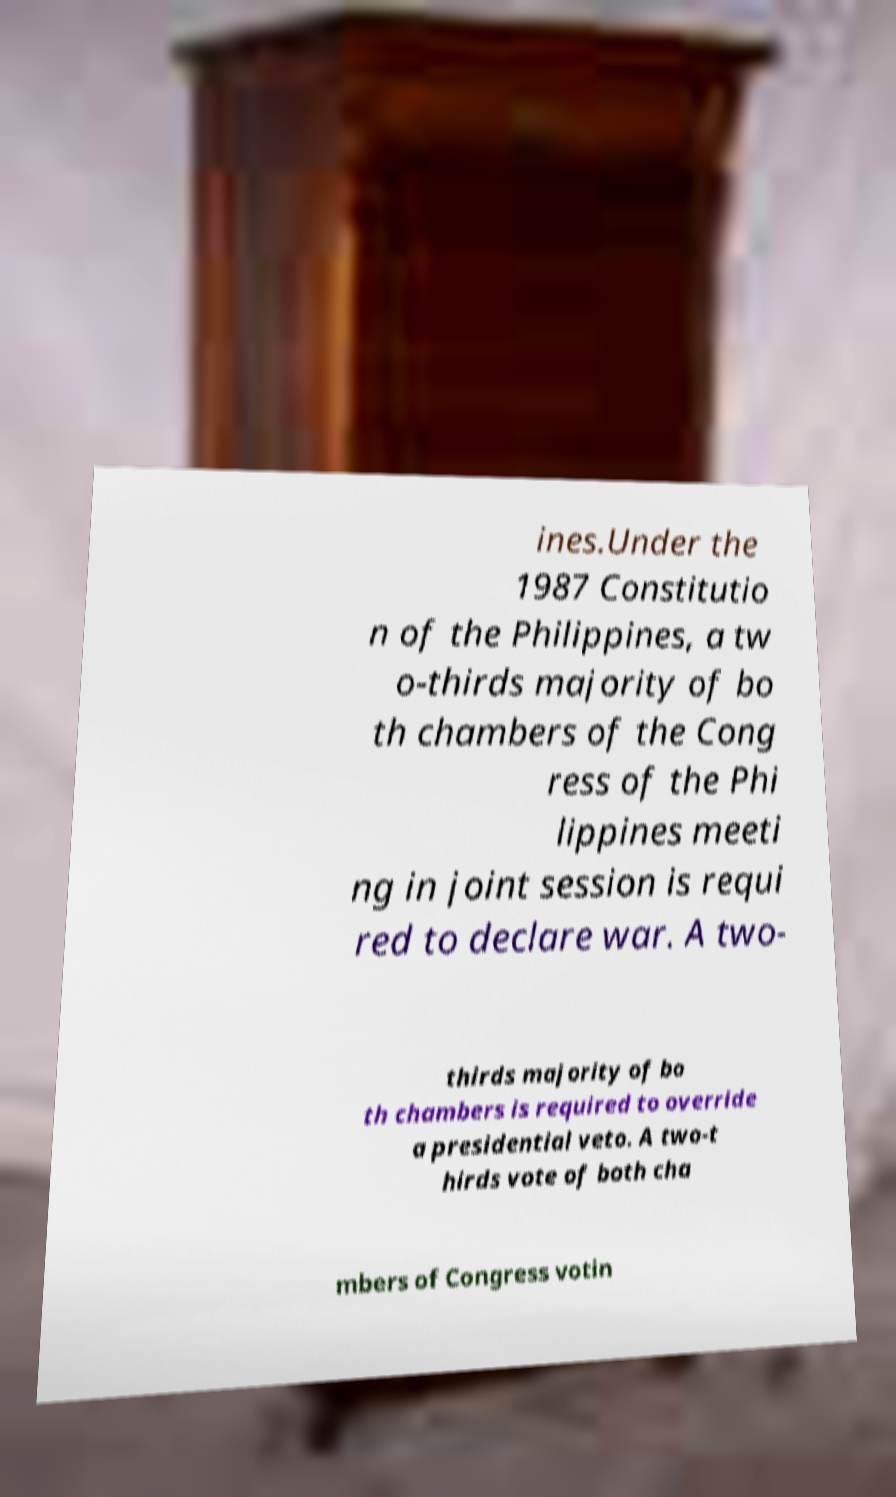Please read and relay the text visible in this image. What does it say? ines.Under the 1987 Constitutio n of the Philippines, a tw o-thirds majority of bo th chambers of the Cong ress of the Phi lippines meeti ng in joint session is requi red to declare war. A two- thirds majority of bo th chambers is required to override a presidential veto. A two-t hirds vote of both cha mbers of Congress votin 